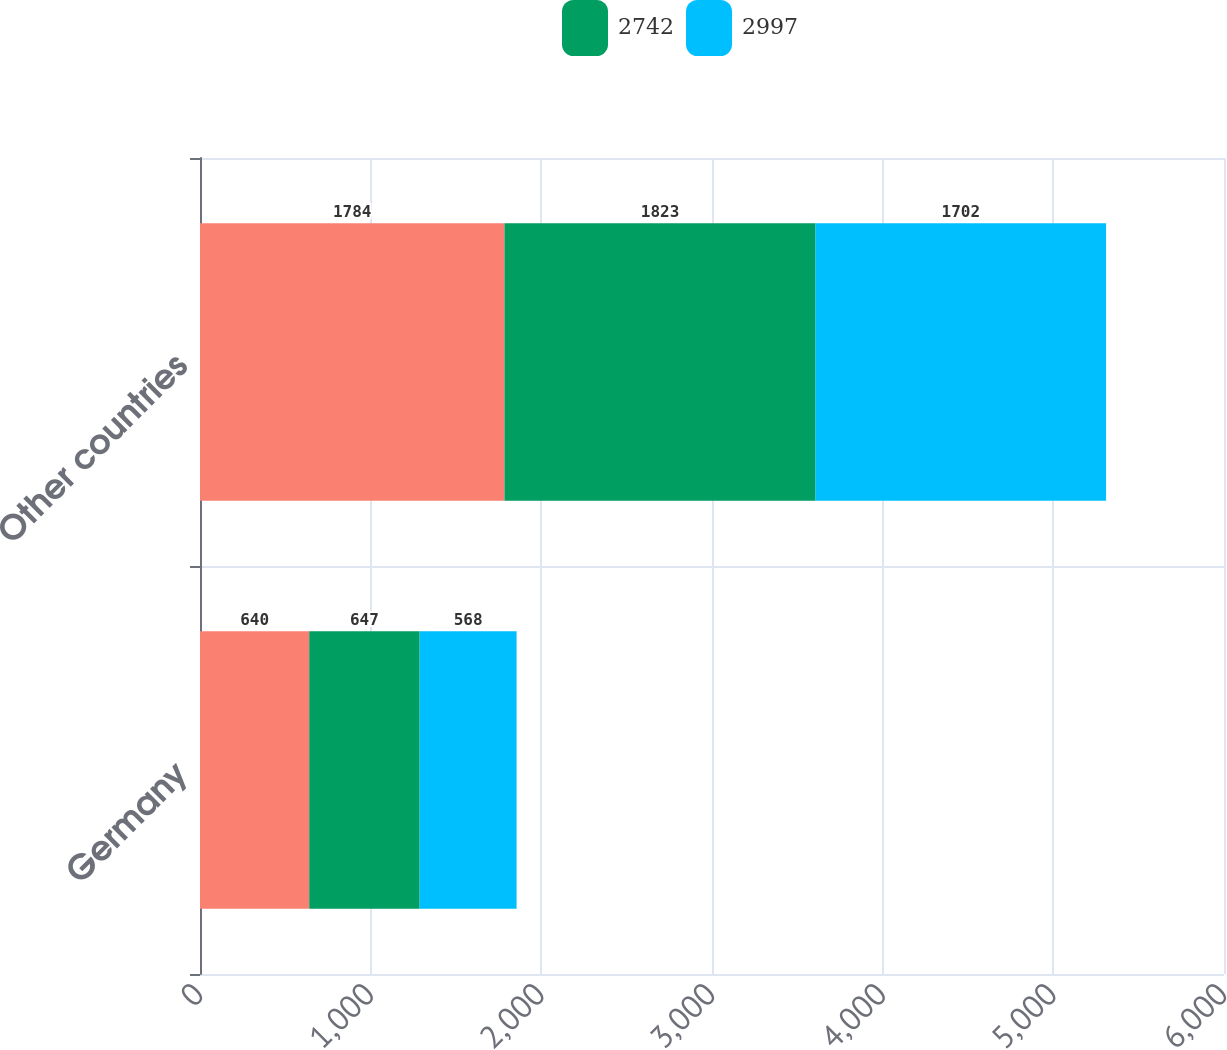Convert chart to OTSL. <chart><loc_0><loc_0><loc_500><loc_500><stacked_bar_chart><ecel><fcel>Germany<fcel>Other countries<nl><fcel>nan<fcel>640<fcel>1784<nl><fcel>2742<fcel>647<fcel>1823<nl><fcel>2997<fcel>568<fcel>1702<nl></chart> 